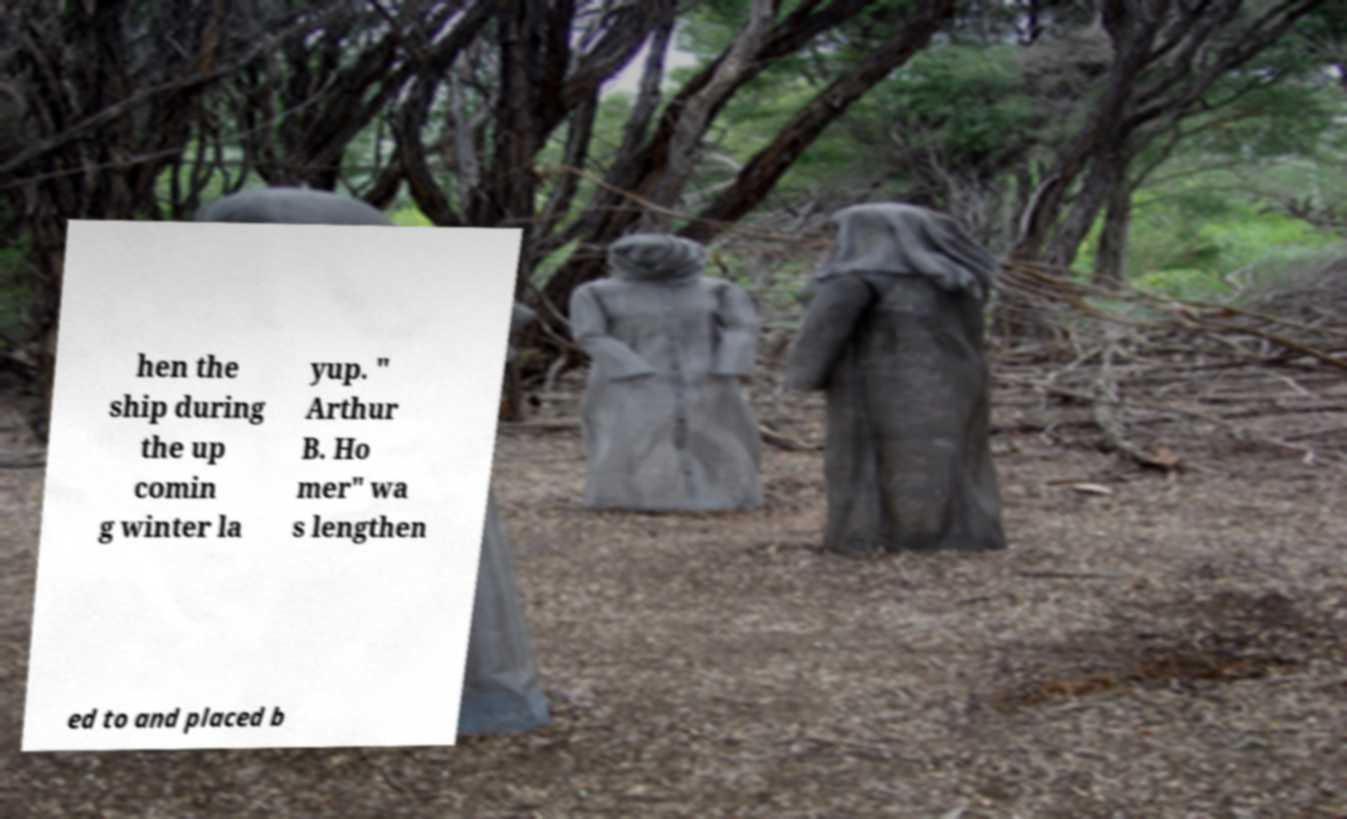Could you assist in decoding the text presented in this image and type it out clearly? hen the ship during the up comin g winter la yup. " Arthur B. Ho mer" wa s lengthen ed to and placed b 